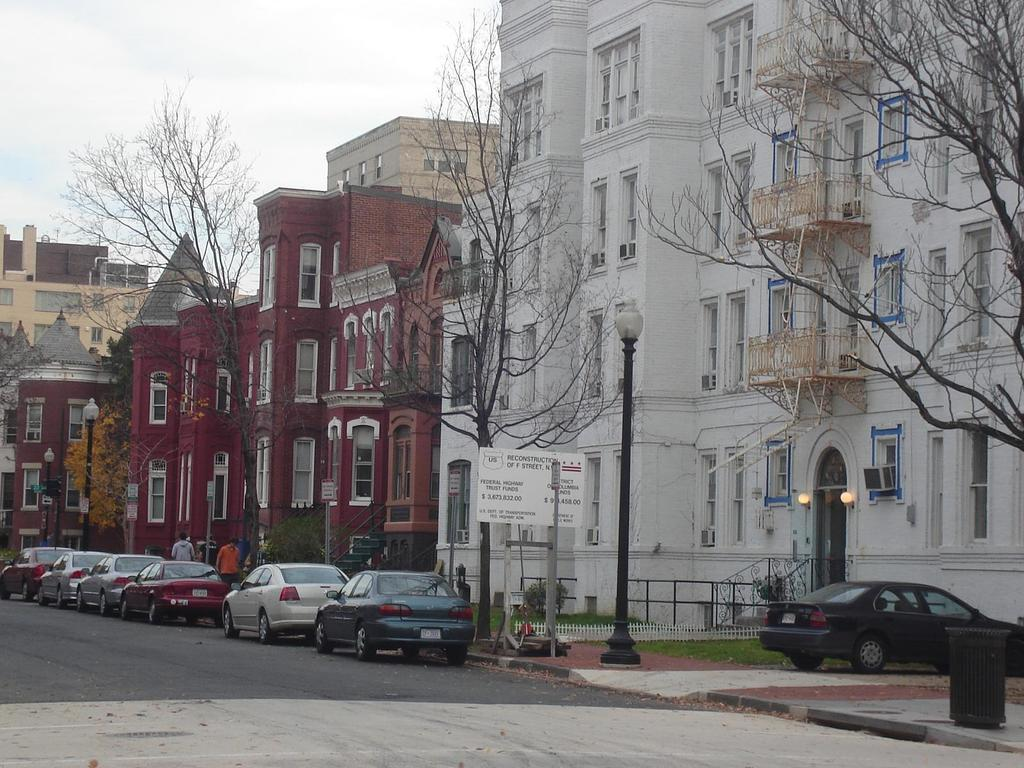What is located in the center of the image? There are buildings in the center of the image. What can be seen at the bottom of the image? There are cars on the road at the bottom of the image. What are the people in the image doing? There are people walking in the image. What objects are present in the image that are used for supporting or holding things? There are poles in the image. What is used for disposing of waste in the image? There is a bin in the image. What is visible at the top of the image? The sky is visible at the top of the image. Can you provide an example of a cent in the image? There is no mention of a cent or currency in the image; it features buildings, cars, people, poles, a bin, and the sky. What type of map is visible in the image? There is no map present in the image. 